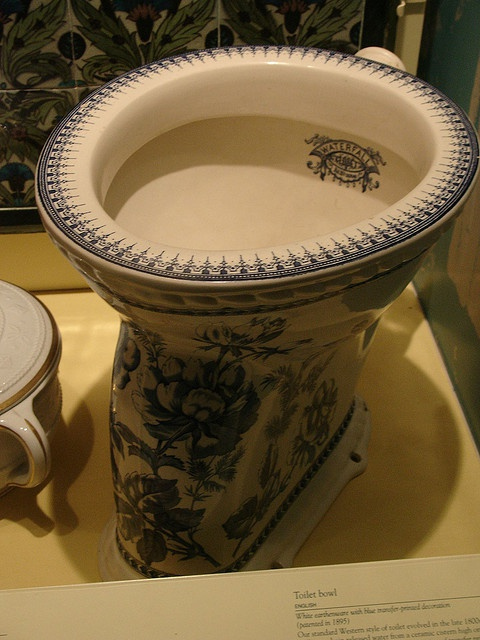Describe the objects in this image and their specific colors. I can see a toilet in black and tan tones in this image. 